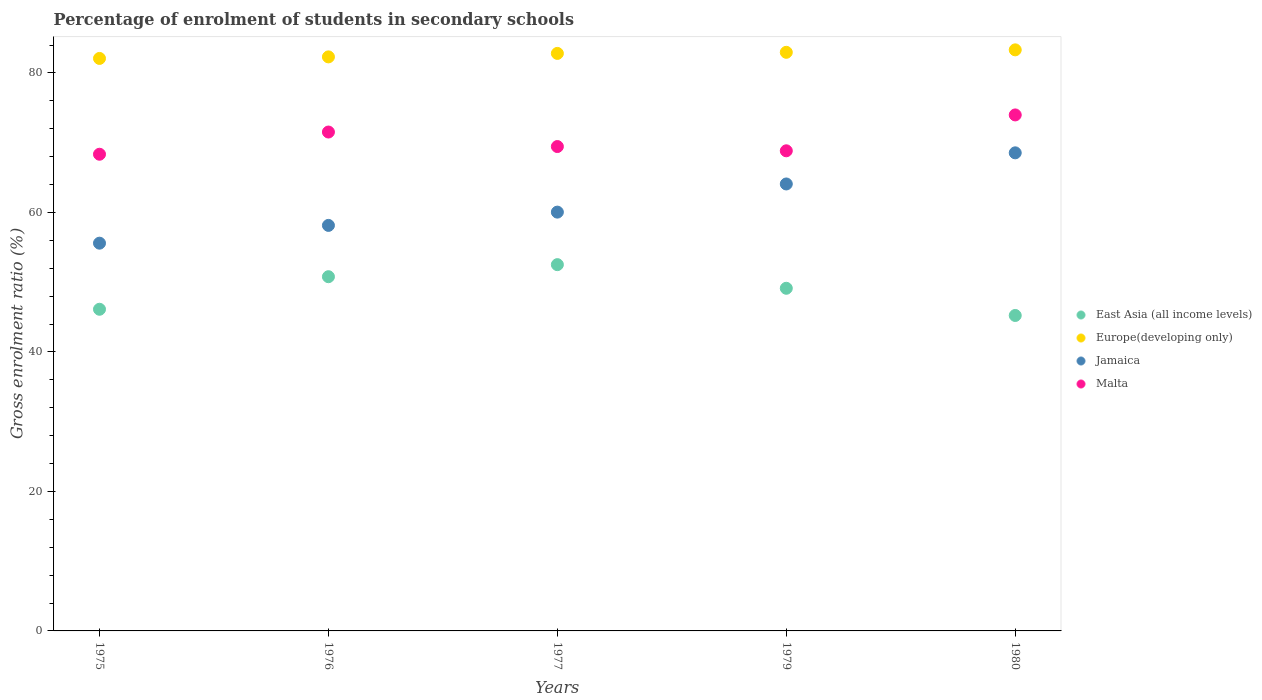How many different coloured dotlines are there?
Offer a very short reply. 4. Is the number of dotlines equal to the number of legend labels?
Your answer should be very brief. Yes. What is the percentage of students enrolled in secondary schools in Malta in 1980?
Your answer should be compact. 73.98. Across all years, what is the maximum percentage of students enrolled in secondary schools in Malta?
Ensure brevity in your answer.  73.98. Across all years, what is the minimum percentage of students enrolled in secondary schools in Jamaica?
Your answer should be compact. 55.59. In which year was the percentage of students enrolled in secondary schools in Jamaica minimum?
Your response must be concise. 1975. What is the total percentage of students enrolled in secondary schools in East Asia (all income levels) in the graph?
Your response must be concise. 243.76. What is the difference between the percentage of students enrolled in secondary schools in East Asia (all income levels) in 1976 and that in 1977?
Keep it short and to the point. -1.73. What is the difference between the percentage of students enrolled in secondary schools in Malta in 1975 and the percentage of students enrolled in secondary schools in Jamaica in 1980?
Your response must be concise. -0.2. What is the average percentage of students enrolled in secondary schools in Malta per year?
Ensure brevity in your answer.  70.43. In the year 1975, what is the difference between the percentage of students enrolled in secondary schools in East Asia (all income levels) and percentage of students enrolled in secondary schools in Europe(developing only)?
Your answer should be very brief. -35.96. In how many years, is the percentage of students enrolled in secondary schools in East Asia (all income levels) greater than 56 %?
Keep it short and to the point. 0. What is the ratio of the percentage of students enrolled in secondary schools in Jamaica in 1977 to that in 1980?
Ensure brevity in your answer.  0.88. Is the percentage of students enrolled in secondary schools in Europe(developing only) in 1976 less than that in 1980?
Make the answer very short. Yes. What is the difference between the highest and the second highest percentage of students enrolled in secondary schools in Malta?
Provide a succinct answer. 2.45. What is the difference between the highest and the lowest percentage of students enrolled in secondary schools in Malta?
Provide a short and direct response. 5.64. Is it the case that in every year, the sum of the percentage of students enrolled in secondary schools in Malta and percentage of students enrolled in secondary schools in Jamaica  is greater than the percentage of students enrolled in secondary schools in East Asia (all income levels)?
Offer a very short reply. Yes. Does the percentage of students enrolled in secondary schools in Malta monotonically increase over the years?
Keep it short and to the point. No. How many dotlines are there?
Offer a very short reply. 4. How many years are there in the graph?
Ensure brevity in your answer.  5. What is the difference between two consecutive major ticks on the Y-axis?
Ensure brevity in your answer.  20. Does the graph contain any zero values?
Provide a succinct answer. No. Does the graph contain grids?
Offer a very short reply. No. How many legend labels are there?
Provide a succinct answer. 4. How are the legend labels stacked?
Your answer should be very brief. Vertical. What is the title of the graph?
Make the answer very short. Percentage of enrolment of students in secondary schools. Does "Northern Mariana Islands" appear as one of the legend labels in the graph?
Give a very brief answer. No. What is the label or title of the Y-axis?
Keep it short and to the point. Gross enrolment ratio (%). What is the Gross enrolment ratio (%) of East Asia (all income levels) in 1975?
Your answer should be very brief. 46.12. What is the Gross enrolment ratio (%) in Europe(developing only) in 1975?
Your response must be concise. 82.08. What is the Gross enrolment ratio (%) of Jamaica in 1975?
Provide a short and direct response. 55.59. What is the Gross enrolment ratio (%) in Malta in 1975?
Provide a succinct answer. 68.34. What is the Gross enrolment ratio (%) in East Asia (all income levels) in 1976?
Offer a very short reply. 50.78. What is the Gross enrolment ratio (%) of Europe(developing only) in 1976?
Ensure brevity in your answer.  82.3. What is the Gross enrolment ratio (%) of Jamaica in 1976?
Provide a short and direct response. 58.14. What is the Gross enrolment ratio (%) in Malta in 1976?
Keep it short and to the point. 71.53. What is the Gross enrolment ratio (%) in East Asia (all income levels) in 1977?
Your answer should be compact. 52.51. What is the Gross enrolment ratio (%) in Europe(developing only) in 1977?
Offer a very short reply. 82.8. What is the Gross enrolment ratio (%) of Jamaica in 1977?
Provide a succinct answer. 60.04. What is the Gross enrolment ratio (%) in Malta in 1977?
Your answer should be very brief. 69.45. What is the Gross enrolment ratio (%) in East Asia (all income levels) in 1979?
Give a very brief answer. 49.12. What is the Gross enrolment ratio (%) in Europe(developing only) in 1979?
Offer a very short reply. 82.95. What is the Gross enrolment ratio (%) of Jamaica in 1979?
Give a very brief answer. 64.08. What is the Gross enrolment ratio (%) in Malta in 1979?
Your answer should be compact. 68.83. What is the Gross enrolment ratio (%) of East Asia (all income levels) in 1980?
Offer a terse response. 45.23. What is the Gross enrolment ratio (%) in Europe(developing only) in 1980?
Provide a succinct answer. 83.31. What is the Gross enrolment ratio (%) in Jamaica in 1980?
Your answer should be compact. 68.54. What is the Gross enrolment ratio (%) in Malta in 1980?
Provide a succinct answer. 73.98. Across all years, what is the maximum Gross enrolment ratio (%) of East Asia (all income levels)?
Your answer should be very brief. 52.51. Across all years, what is the maximum Gross enrolment ratio (%) in Europe(developing only)?
Your response must be concise. 83.31. Across all years, what is the maximum Gross enrolment ratio (%) of Jamaica?
Ensure brevity in your answer.  68.54. Across all years, what is the maximum Gross enrolment ratio (%) of Malta?
Your answer should be very brief. 73.98. Across all years, what is the minimum Gross enrolment ratio (%) of East Asia (all income levels)?
Your answer should be compact. 45.23. Across all years, what is the minimum Gross enrolment ratio (%) in Europe(developing only)?
Your answer should be very brief. 82.08. Across all years, what is the minimum Gross enrolment ratio (%) of Jamaica?
Give a very brief answer. 55.59. Across all years, what is the minimum Gross enrolment ratio (%) of Malta?
Your answer should be compact. 68.34. What is the total Gross enrolment ratio (%) in East Asia (all income levels) in the graph?
Your answer should be compact. 243.76. What is the total Gross enrolment ratio (%) in Europe(developing only) in the graph?
Your answer should be very brief. 413.44. What is the total Gross enrolment ratio (%) in Jamaica in the graph?
Provide a succinct answer. 306.4. What is the total Gross enrolment ratio (%) of Malta in the graph?
Provide a short and direct response. 352.13. What is the difference between the Gross enrolment ratio (%) of East Asia (all income levels) in 1975 and that in 1976?
Provide a succinct answer. -4.67. What is the difference between the Gross enrolment ratio (%) of Europe(developing only) in 1975 and that in 1976?
Provide a short and direct response. -0.22. What is the difference between the Gross enrolment ratio (%) of Jamaica in 1975 and that in 1976?
Your answer should be compact. -2.55. What is the difference between the Gross enrolment ratio (%) in Malta in 1975 and that in 1976?
Ensure brevity in your answer.  -3.18. What is the difference between the Gross enrolment ratio (%) in East Asia (all income levels) in 1975 and that in 1977?
Your response must be concise. -6.4. What is the difference between the Gross enrolment ratio (%) of Europe(developing only) in 1975 and that in 1977?
Make the answer very short. -0.72. What is the difference between the Gross enrolment ratio (%) of Jamaica in 1975 and that in 1977?
Offer a terse response. -4.45. What is the difference between the Gross enrolment ratio (%) of Malta in 1975 and that in 1977?
Provide a short and direct response. -1.1. What is the difference between the Gross enrolment ratio (%) in East Asia (all income levels) in 1975 and that in 1979?
Make the answer very short. -3.01. What is the difference between the Gross enrolment ratio (%) of Europe(developing only) in 1975 and that in 1979?
Provide a short and direct response. -0.88. What is the difference between the Gross enrolment ratio (%) in Jamaica in 1975 and that in 1979?
Provide a succinct answer. -8.49. What is the difference between the Gross enrolment ratio (%) in Malta in 1975 and that in 1979?
Offer a very short reply. -0.49. What is the difference between the Gross enrolment ratio (%) of East Asia (all income levels) in 1975 and that in 1980?
Your response must be concise. 0.89. What is the difference between the Gross enrolment ratio (%) in Europe(developing only) in 1975 and that in 1980?
Ensure brevity in your answer.  -1.23. What is the difference between the Gross enrolment ratio (%) of Jamaica in 1975 and that in 1980?
Your answer should be very brief. -12.95. What is the difference between the Gross enrolment ratio (%) in Malta in 1975 and that in 1980?
Your response must be concise. -5.64. What is the difference between the Gross enrolment ratio (%) of East Asia (all income levels) in 1976 and that in 1977?
Your answer should be very brief. -1.73. What is the difference between the Gross enrolment ratio (%) in Europe(developing only) in 1976 and that in 1977?
Make the answer very short. -0.5. What is the difference between the Gross enrolment ratio (%) in Jamaica in 1976 and that in 1977?
Keep it short and to the point. -1.9. What is the difference between the Gross enrolment ratio (%) in Malta in 1976 and that in 1977?
Your answer should be very brief. 2.08. What is the difference between the Gross enrolment ratio (%) in East Asia (all income levels) in 1976 and that in 1979?
Your answer should be compact. 1.66. What is the difference between the Gross enrolment ratio (%) of Europe(developing only) in 1976 and that in 1979?
Offer a terse response. -0.66. What is the difference between the Gross enrolment ratio (%) in Jamaica in 1976 and that in 1979?
Provide a succinct answer. -5.94. What is the difference between the Gross enrolment ratio (%) of Malta in 1976 and that in 1979?
Your response must be concise. 2.69. What is the difference between the Gross enrolment ratio (%) of East Asia (all income levels) in 1976 and that in 1980?
Offer a terse response. 5.56. What is the difference between the Gross enrolment ratio (%) of Europe(developing only) in 1976 and that in 1980?
Offer a very short reply. -1.01. What is the difference between the Gross enrolment ratio (%) in Jamaica in 1976 and that in 1980?
Ensure brevity in your answer.  -10.4. What is the difference between the Gross enrolment ratio (%) in Malta in 1976 and that in 1980?
Provide a short and direct response. -2.45. What is the difference between the Gross enrolment ratio (%) in East Asia (all income levels) in 1977 and that in 1979?
Provide a short and direct response. 3.39. What is the difference between the Gross enrolment ratio (%) of Europe(developing only) in 1977 and that in 1979?
Provide a succinct answer. -0.16. What is the difference between the Gross enrolment ratio (%) in Jamaica in 1977 and that in 1979?
Your answer should be compact. -4.04. What is the difference between the Gross enrolment ratio (%) in Malta in 1977 and that in 1979?
Make the answer very short. 0.61. What is the difference between the Gross enrolment ratio (%) in East Asia (all income levels) in 1977 and that in 1980?
Ensure brevity in your answer.  7.29. What is the difference between the Gross enrolment ratio (%) of Europe(developing only) in 1977 and that in 1980?
Your answer should be compact. -0.51. What is the difference between the Gross enrolment ratio (%) in Jamaica in 1977 and that in 1980?
Your answer should be compact. -8.5. What is the difference between the Gross enrolment ratio (%) of Malta in 1977 and that in 1980?
Make the answer very short. -4.53. What is the difference between the Gross enrolment ratio (%) of East Asia (all income levels) in 1979 and that in 1980?
Your answer should be compact. 3.9. What is the difference between the Gross enrolment ratio (%) in Europe(developing only) in 1979 and that in 1980?
Provide a succinct answer. -0.35. What is the difference between the Gross enrolment ratio (%) of Jamaica in 1979 and that in 1980?
Your response must be concise. -4.46. What is the difference between the Gross enrolment ratio (%) of Malta in 1979 and that in 1980?
Your response must be concise. -5.14. What is the difference between the Gross enrolment ratio (%) in East Asia (all income levels) in 1975 and the Gross enrolment ratio (%) in Europe(developing only) in 1976?
Your response must be concise. -36.18. What is the difference between the Gross enrolment ratio (%) of East Asia (all income levels) in 1975 and the Gross enrolment ratio (%) of Jamaica in 1976?
Make the answer very short. -12.02. What is the difference between the Gross enrolment ratio (%) in East Asia (all income levels) in 1975 and the Gross enrolment ratio (%) in Malta in 1976?
Make the answer very short. -25.41. What is the difference between the Gross enrolment ratio (%) in Europe(developing only) in 1975 and the Gross enrolment ratio (%) in Jamaica in 1976?
Make the answer very short. 23.94. What is the difference between the Gross enrolment ratio (%) of Europe(developing only) in 1975 and the Gross enrolment ratio (%) of Malta in 1976?
Give a very brief answer. 10.55. What is the difference between the Gross enrolment ratio (%) of Jamaica in 1975 and the Gross enrolment ratio (%) of Malta in 1976?
Offer a terse response. -15.93. What is the difference between the Gross enrolment ratio (%) of East Asia (all income levels) in 1975 and the Gross enrolment ratio (%) of Europe(developing only) in 1977?
Offer a terse response. -36.68. What is the difference between the Gross enrolment ratio (%) in East Asia (all income levels) in 1975 and the Gross enrolment ratio (%) in Jamaica in 1977?
Ensure brevity in your answer.  -13.93. What is the difference between the Gross enrolment ratio (%) of East Asia (all income levels) in 1975 and the Gross enrolment ratio (%) of Malta in 1977?
Ensure brevity in your answer.  -23.33. What is the difference between the Gross enrolment ratio (%) in Europe(developing only) in 1975 and the Gross enrolment ratio (%) in Jamaica in 1977?
Your answer should be compact. 22.03. What is the difference between the Gross enrolment ratio (%) in Europe(developing only) in 1975 and the Gross enrolment ratio (%) in Malta in 1977?
Provide a short and direct response. 12.63. What is the difference between the Gross enrolment ratio (%) in Jamaica in 1975 and the Gross enrolment ratio (%) in Malta in 1977?
Ensure brevity in your answer.  -13.85. What is the difference between the Gross enrolment ratio (%) in East Asia (all income levels) in 1975 and the Gross enrolment ratio (%) in Europe(developing only) in 1979?
Your answer should be compact. -36.84. What is the difference between the Gross enrolment ratio (%) in East Asia (all income levels) in 1975 and the Gross enrolment ratio (%) in Jamaica in 1979?
Your answer should be compact. -17.96. What is the difference between the Gross enrolment ratio (%) in East Asia (all income levels) in 1975 and the Gross enrolment ratio (%) in Malta in 1979?
Offer a very short reply. -22.72. What is the difference between the Gross enrolment ratio (%) in Europe(developing only) in 1975 and the Gross enrolment ratio (%) in Jamaica in 1979?
Ensure brevity in your answer.  18. What is the difference between the Gross enrolment ratio (%) of Europe(developing only) in 1975 and the Gross enrolment ratio (%) of Malta in 1979?
Your answer should be compact. 13.24. What is the difference between the Gross enrolment ratio (%) of Jamaica in 1975 and the Gross enrolment ratio (%) of Malta in 1979?
Offer a very short reply. -13.24. What is the difference between the Gross enrolment ratio (%) of East Asia (all income levels) in 1975 and the Gross enrolment ratio (%) of Europe(developing only) in 1980?
Provide a succinct answer. -37.19. What is the difference between the Gross enrolment ratio (%) of East Asia (all income levels) in 1975 and the Gross enrolment ratio (%) of Jamaica in 1980?
Provide a short and direct response. -22.43. What is the difference between the Gross enrolment ratio (%) of East Asia (all income levels) in 1975 and the Gross enrolment ratio (%) of Malta in 1980?
Your answer should be compact. -27.86. What is the difference between the Gross enrolment ratio (%) in Europe(developing only) in 1975 and the Gross enrolment ratio (%) in Jamaica in 1980?
Provide a succinct answer. 13.54. What is the difference between the Gross enrolment ratio (%) in Europe(developing only) in 1975 and the Gross enrolment ratio (%) in Malta in 1980?
Provide a succinct answer. 8.1. What is the difference between the Gross enrolment ratio (%) of Jamaica in 1975 and the Gross enrolment ratio (%) of Malta in 1980?
Offer a very short reply. -18.39. What is the difference between the Gross enrolment ratio (%) of East Asia (all income levels) in 1976 and the Gross enrolment ratio (%) of Europe(developing only) in 1977?
Offer a terse response. -32.01. What is the difference between the Gross enrolment ratio (%) of East Asia (all income levels) in 1976 and the Gross enrolment ratio (%) of Jamaica in 1977?
Keep it short and to the point. -9.26. What is the difference between the Gross enrolment ratio (%) of East Asia (all income levels) in 1976 and the Gross enrolment ratio (%) of Malta in 1977?
Ensure brevity in your answer.  -18.66. What is the difference between the Gross enrolment ratio (%) in Europe(developing only) in 1976 and the Gross enrolment ratio (%) in Jamaica in 1977?
Your response must be concise. 22.26. What is the difference between the Gross enrolment ratio (%) in Europe(developing only) in 1976 and the Gross enrolment ratio (%) in Malta in 1977?
Make the answer very short. 12.85. What is the difference between the Gross enrolment ratio (%) in Jamaica in 1976 and the Gross enrolment ratio (%) in Malta in 1977?
Provide a short and direct response. -11.31. What is the difference between the Gross enrolment ratio (%) of East Asia (all income levels) in 1976 and the Gross enrolment ratio (%) of Europe(developing only) in 1979?
Offer a terse response. -32.17. What is the difference between the Gross enrolment ratio (%) in East Asia (all income levels) in 1976 and the Gross enrolment ratio (%) in Jamaica in 1979?
Your answer should be very brief. -13.3. What is the difference between the Gross enrolment ratio (%) of East Asia (all income levels) in 1976 and the Gross enrolment ratio (%) of Malta in 1979?
Offer a very short reply. -18.05. What is the difference between the Gross enrolment ratio (%) of Europe(developing only) in 1976 and the Gross enrolment ratio (%) of Jamaica in 1979?
Your answer should be very brief. 18.22. What is the difference between the Gross enrolment ratio (%) of Europe(developing only) in 1976 and the Gross enrolment ratio (%) of Malta in 1979?
Provide a succinct answer. 13.46. What is the difference between the Gross enrolment ratio (%) in Jamaica in 1976 and the Gross enrolment ratio (%) in Malta in 1979?
Ensure brevity in your answer.  -10.7. What is the difference between the Gross enrolment ratio (%) of East Asia (all income levels) in 1976 and the Gross enrolment ratio (%) of Europe(developing only) in 1980?
Your answer should be compact. -32.52. What is the difference between the Gross enrolment ratio (%) in East Asia (all income levels) in 1976 and the Gross enrolment ratio (%) in Jamaica in 1980?
Your answer should be compact. -17.76. What is the difference between the Gross enrolment ratio (%) in East Asia (all income levels) in 1976 and the Gross enrolment ratio (%) in Malta in 1980?
Ensure brevity in your answer.  -23.19. What is the difference between the Gross enrolment ratio (%) in Europe(developing only) in 1976 and the Gross enrolment ratio (%) in Jamaica in 1980?
Your answer should be compact. 13.76. What is the difference between the Gross enrolment ratio (%) of Europe(developing only) in 1976 and the Gross enrolment ratio (%) of Malta in 1980?
Give a very brief answer. 8.32. What is the difference between the Gross enrolment ratio (%) in Jamaica in 1976 and the Gross enrolment ratio (%) in Malta in 1980?
Offer a very short reply. -15.84. What is the difference between the Gross enrolment ratio (%) in East Asia (all income levels) in 1977 and the Gross enrolment ratio (%) in Europe(developing only) in 1979?
Give a very brief answer. -30.44. What is the difference between the Gross enrolment ratio (%) of East Asia (all income levels) in 1977 and the Gross enrolment ratio (%) of Jamaica in 1979?
Offer a very short reply. -11.57. What is the difference between the Gross enrolment ratio (%) of East Asia (all income levels) in 1977 and the Gross enrolment ratio (%) of Malta in 1979?
Your response must be concise. -16.32. What is the difference between the Gross enrolment ratio (%) in Europe(developing only) in 1977 and the Gross enrolment ratio (%) in Jamaica in 1979?
Offer a terse response. 18.72. What is the difference between the Gross enrolment ratio (%) in Europe(developing only) in 1977 and the Gross enrolment ratio (%) in Malta in 1979?
Provide a succinct answer. 13.96. What is the difference between the Gross enrolment ratio (%) in Jamaica in 1977 and the Gross enrolment ratio (%) in Malta in 1979?
Keep it short and to the point. -8.79. What is the difference between the Gross enrolment ratio (%) of East Asia (all income levels) in 1977 and the Gross enrolment ratio (%) of Europe(developing only) in 1980?
Your response must be concise. -30.79. What is the difference between the Gross enrolment ratio (%) in East Asia (all income levels) in 1977 and the Gross enrolment ratio (%) in Jamaica in 1980?
Keep it short and to the point. -16.03. What is the difference between the Gross enrolment ratio (%) of East Asia (all income levels) in 1977 and the Gross enrolment ratio (%) of Malta in 1980?
Offer a terse response. -21.47. What is the difference between the Gross enrolment ratio (%) in Europe(developing only) in 1977 and the Gross enrolment ratio (%) in Jamaica in 1980?
Your answer should be compact. 14.26. What is the difference between the Gross enrolment ratio (%) of Europe(developing only) in 1977 and the Gross enrolment ratio (%) of Malta in 1980?
Ensure brevity in your answer.  8.82. What is the difference between the Gross enrolment ratio (%) in Jamaica in 1977 and the Gross enrolment ratio (%) in Malta in 1980?
Provide a short and direct response. -13.93. What is the difference between the Gross enrolment ratio (%) of East Asia (all income levels) in 1979 and the Gross enrolment ratio (%) of Europe(developing only) in 1980?
Your answer should be very brief. -34.18. What is the difference between the Gross enrolment ratio (%) in East Asia (all income levels) in 1979 and the Gross enrolment ratio (%) in Jamaica in 1980?
Your answer should be very brief. -19.42. What is the difference between the Gross enrolment ratio (%) of East Asia (all income levels) in 1979 and the Gross enrolment ratio (%) of Malta in 1980?
Your answer should be very brief. -24.85. What is the difference between the Gross enrolment ratio (%) in Europe(developing only) in 1979 and the Gross enrolment ratio (%) in Jamaica in 1980?
Offer a terse response. 14.41. What is the difference between the Gross enrolment ratio (%) of Europe(developing only) in 1979 and the Gross enrolment ratio (%) of Malta in 1980?
Your answer should be compact. 8.98. What is the difference between the Gross enrolment ratio (%) in Jamaica in 1979 and the Gross enrolment ratio (%) in Malta in 1980?
Provide a short and direct response. -9.9. What is the average Gross enrolment ratio (%) in East Asia (all income levels) per year?
Your response must be concise. 48.75. What is the average Gross enrolment ratio (%) in Europe(developing only) per year?
Make the answer very short. 82.69. What is the average Gross enrolment ratio (%) in Jamaica per year?
Give a very brief answer. 61.28. What is the average Gross enrolment ratio (%) in Malta per year?
Your answer should be very brief. 70.43. In the year 1975, what is the difference between the Gross enrolment ratio (%) of East Asia (all income levels) and Gross enrolment ratio (%) of Europe(developing only)?
Your answer should be compact. -35.96. In the year 1975, what is the difference between the Gross enrolment ratio (%) in East Asia (all income levels) and Gross enrolment ratio (%) in Jamaica?
Offer a terse response. -9.47. In the year 1975, what is the difference between the Gross enrolment ratio (%) in East Asia (all income levels) and Gross enrolment ratio (%) in Malta?
Offer a very short reply. -22.23. In the year 1975, what is the difference between the Gross enrolment ratio (%) of Europe(developing only) and Gross enrolment ratio (%) of Jamaica?
Provide a short and direct response. 26.49. In the year 1975, what is the difference between the Gross enrolment ratio (%) in Europe(developing only) and Gross enrolment ratio (%) in Malta?
Offer a terse response. 13.74. In the year 1975, what is the difference between the Gross enrolment ratio (%) of Jamaica and Gross enrolment ratio (%) of Malta?
Your answer should be compact. -12.75. In the year 1976, what is the difference between the Gross enrolment ratio (%) of East Asia (all income levels) and Gross enrolment ratio (%) of Europe(developing only)?
Provide a short and direct response. -31.52. In the year 1976, what is the difference between the Gross enrolment ratio (%) of East Asia (all income levels) and Gross enrolment ratio (%) of Jamaica?
Offer a terse response. -7.36. In the year 1976, what is the difference between the Gross enrolment ratio (%) in East Asia (all income levels) and Gross enrolment ratio (%) in Malta?
Your answer should be compact. -20.74. In the year 1976, what is the difference between the Gross enrolment ratio (%) in Europe(developing only) and Gross enrolment ratio (%) in Jamaica?
Offer a terse response. 24.16. In the year 1976, what is the difference between the Gross enrolment ratio (%) in Europe(developing only) and Gross enrolment ratio (%) in Malta?
Provide a short and direct response. 10.77. In the year 1976, what is the difference between the Gross enrolment ratio (%) of Jamaica and Gross enrolment ratio (%) of Malta?
Your answer should be very brief. -13.39. In the year 1977, what is the difference between the Gross enrolment ratio (%) in East Asia (all income levels) and Gross enrolment ratio (%) in Europe(developing only)?
Your answer should be very brief. -30.29. In the year 1977, what is the difference between the Gross enrolment ratio (%) in East Asia (all income levels) and Gross enrolment ratio (%) in Jamaica?
Make the answer very short. -7.53. In the year 1977, what is the difference between the Gross enrolment ratio (%) of East Asia (all income levels) and Gross enrolment ratio (%) of Malta?
Your answer should be very brief. -16.93. In the year 1977, what is the difference between the Gross enrolment ratio (%) of Europe(developing only) and Gross enrolment ratio (%) of Jamaica?
Provide a short and direct response. 22.75. In the year 1977, what is the difference between the Gross enrolment ratio (%) of Europe(developing only) and Gross enrolment ratio (%) of Malta?
Provide a succinct answer. 13.35. In the year 1977, what is the difference between the Gross enrolment ratio (%) of Jamaica and Gross enrolment ratio (%) of Malta?
Offer a terse response. -9.4. In the year 1979, what is the difference between the Gross enrolment ratio (%) in East Asia (all income levels) and Gross enrolment ratio (%) in Europe(developing only)?
Offer a very short reply. -33.83. In the year 1979, what is the difference between the Gross enrolment ratio (%) of East Asia (all income levels) and Gross enrolment ratio (%) of Jamaica?
Make the answer very short. -14.96. In the year 1979, what is the difference between the Gross enrolment ratio (%) in East Asia (all income levels) and Gross enrolment ratio (%) in Malta?
Make the answer very short. -19.71. In the year 1979, what is the difference between the Gross enrolment ratio (%) of Europe(developing only) and Gross enrolment ratio (%) of Jamaica?
Provide a succinct answer. 18.88. In the year 1979, what is the difference between the Gross enrolment ratio (%) of Europe(developing only) and Gross enrolment ratio (%) of Malta?
Your answer should be very brief. 14.12. In the year 1979, what is the difference between the Gross enrolment ratio (%) in Jamaica and Gross enrolment ratio (%) in Malta?
Provide a succinct answer. -4.75. In the year 1980, what is the difference between the Gross enrolment ratio (%) in East Asia (all income levels) and Gross enrolment ratio (%) in Europe(developing only)?
Ensure brevity in your answer.  -38.08. In the year 1980, what is the difference between the Gross enrolment ratio (%) in East Asia (all income levels) and Gross enrolment ratio (%) in Jamaica?
Provide a short and direct response. -23.32. In the year 1980, what is the difference between the Gross enrolment ratio (%) in East Asia (all income levels) and Gross enrolment ratio (%) in Malta?
Your response must be concise. -28.75. In the year 1980, what is the difference between the Gross enrolment ratio (%) of Europe(developing only) and Gross enrolment ratio (%) of Jamaica?
Your answer should be compact. 14.76. In the year 1980, what is the difference between the Gross enrolment ratio (%) in Europe(developing only) and Gross enrolment ratio (%) in Malta?
Offer a terse response. 9.33. In the year 1980, what is the difference between the Gross enrolment ratio (%) of Jamaica and Gross enrolment ratio (%) of Malta?
Keep it short and to the point. -5.44. What is the ratio of the Gross enrolment ratio (%) of East Asia (all income levels) in 1975 to that in 1976?
Ensure brevity in your answer.  0.91. What is the ratio of the Gross enrolment ratio (%) in Jamaica in 1975 to that in 1976?
Make the answer very short. 0.96. What is the ratio of the Gross enrolment ratio (%) of Malta in 1975 to that in 1976?
Offer a very short reply. 0.96. What is the ratio of the Gross enrolment ratio (%) of East Asia (all income levels) in 1975 to that in 1977?
Make the answer very short. 0.88. What is the ratio of the Gross enrolment ratio (%) in Jamaica in 1975 to that in 1977?
Offer a very short reply. 0.93. What is the ratio of the Gross enrolment ratio (%) of Malta in 1975 to that in 1977?
Your answer should be compact. 0.98. What is the ratio of the Gross enrolment ratio (%) in East Asia (all income levels) in 1975 to that in 1979?
Your response must be concise. 0.94. What is the ratio of the Gross enrolment ratio (%) of Jamaica in 1975 to that in 1979?
Your answer should be compact. 0.87. What is the ratio of the Gross enrolment ratio (%) of East Asia (all income levels) in 1975 to that in 1980?
Provide a succinct answer. 1.02. What is the ratio of the Gross enrolment ratio (%) of Europe(developing only) in 1975 to that in 1980?
Give a very brief answer. 0.99. What is the ratio of the Gross enrolment ratio (%) in Jamaica in 1975 to that in 1980?
Give a very brief answer. 0.81. What is the ratio of the Gross enrolment ratio (%) in Malta in 1975 to that in 1980?
Offer a terse response. 0.92. What is the ratio of the Gross enrolment ratio (%) of East Asia (all income levels) in 1976 to that in 1977?
Your response must be concise. 0.97. What is the ratio of the Gross enrolment ratio (%) in Jamaica in 1976 to that in 1977?
Provide a succinct answer. 0.97. What is the ratio of the Gross enrolment ratio (%) of East Asia (all income levels) in 1976 to that in 1979?
Keep it short and to the point. 1.03. What is the ratio of the Gross enrolment ratio (%) of Jamaica in 1976 to that in 1979?
Provide a succinct answer. 0.91. What is the ratio of the Gross enrolment ratio (%) in Malta in 1976 to that in 1979?
Make the answer very short. 1.04. What is the ratio of the Gross enrolment ratio (%) of East Asia (all income levels) in 1976 to that in 1980?
Give a very brief answer. 1.12. What is the ratio of the Gross enrolment ratio (%) of Europe(developing only) in 1976 to that in 1980?
Keep it short and to the point. 0.99. What is the ratio of the Gross enrolment ratio (%) of Jamaica in 1976 to that in 1980?
Provide a succinct answer. 0.85. What is the ratio of the Gross enrolment ratio (%) in Malta in 1976 to that in 1980?
Keep it short and to the point. 0.97. What is the ratio of the Gross enrolment ratio (%) in East Asia (all income levels) in 1977 to that in 1979?
Make the answer very short. 1.07. What is the ratio of the Gross enrolment ratio (%) in Europe(developing only) in 1977 to that in 1979?
Provide a succinct answer. 1. What is the ratio of the Gross enrolment ratio (%) in Jamaica in 1977 to that in 1979?
Give a very brief answer. 0.94. What is the ratio of the Gross enrolment ratio (%) of Malta in 1977 to that in 1979?
Your response must be concise. 1.01. What is the ratio of the Gross enrolment ratio (%) of East Asia (all income levels) in 1977 to that in 1980?
Give a very brief answer. 1.16. What is the ratio of the Gross enrolment ratio (%) of Europe(developing only) in 1977 to that in 1980?
Provide a succinct answer. 0.99. What is the ratio of the Gross enrolment ratio (%) in Jamaica in 1977 to that in 1980?
Your response must be concise. 0.88. What is the ratio of the Gross enrolment ratio (%) in Malta in 1977 to that in 1980?
Give a very brief answer. 0.94. What is the ratio of the Gross enrolment ratio (%) in East Asia (all income levels) in 1979 to that in 1980?
Provide a succinct answer. 1.09. What is the ratio of the Gross enrolment ratio (%) of Jamaica in 1979 to that in 1980?
Provide a succinct answer. 0.93. What is the ratio of the Gross enrolment ratio (%) of Malta in 1979 to that in 1980?
Your answer should be compact. 0.93. What is the difference between the highest and the second highest Gross enrolment ratio (%) of East Asia (all income levels)?
Your response must be concise. 1.73. What is the difference between the highest and the second highest Gross enrolment ratio (%) in Europe(developing only)?
Ensure brevity in your answer.  0.35. What is the difference between the highest and the second highest Gross enrolment ratio (%) in Jamaica?
Give a very brief answer. 4.46. What is the difference between the highest and the second highest Gross enrolment ratio (%) in Malta?
Give a very brief answer. 2.45. What is the difference between the highest and the lowest Gross enrolment ratio (%) of East Asia (all income levels)?
Ensure brevity in your answer.  7.29. What is the difference between the highest and the lowest Gross enrolment ratio (%) in Europe(developing only)?
Your answer should be very brief. 1.23. What is the difference between the highest and the lowest Gross enrolment ratio (%) of Jamaica?
Keep it short and to the point. 12.95. What is the difference between the highest and the lowest Gross enrolment ratio (%) in Malta?
Ensure brevity in your answer.  5.64. 